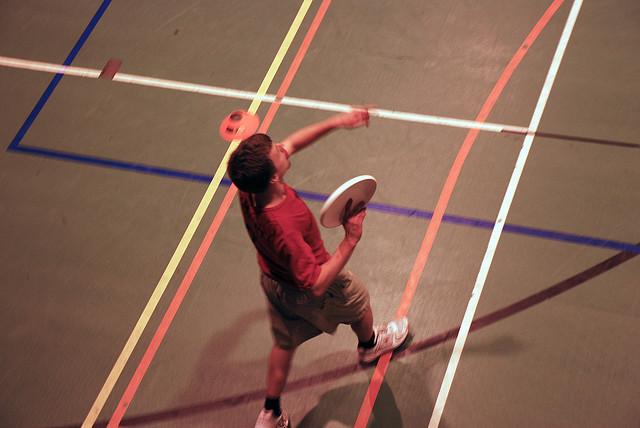Which foot is stepping forward?
Answer briefly. Right. What sport is being played?
Keep it brief. Frisbee. What is in his right hand?
Concise answer only. Frisbee. 